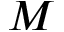Convert formula to latex. <formula><loc_0><loc_0><loc_500><loc_500>M</formula> 